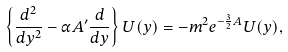Convert formula to latex. <formula><loc_0><loc_0><loc_500><loc_500>\left \{ \frac { d ^ { 2 } } { d y ^ { 2 } } - \alpha A ^ { \prime } \frac { d } { d y } \right \} U ( y ) = - m ^ { 2 } e ^ { - \frac { 3 } { 2 } A } U ( y ) ,</formula> 